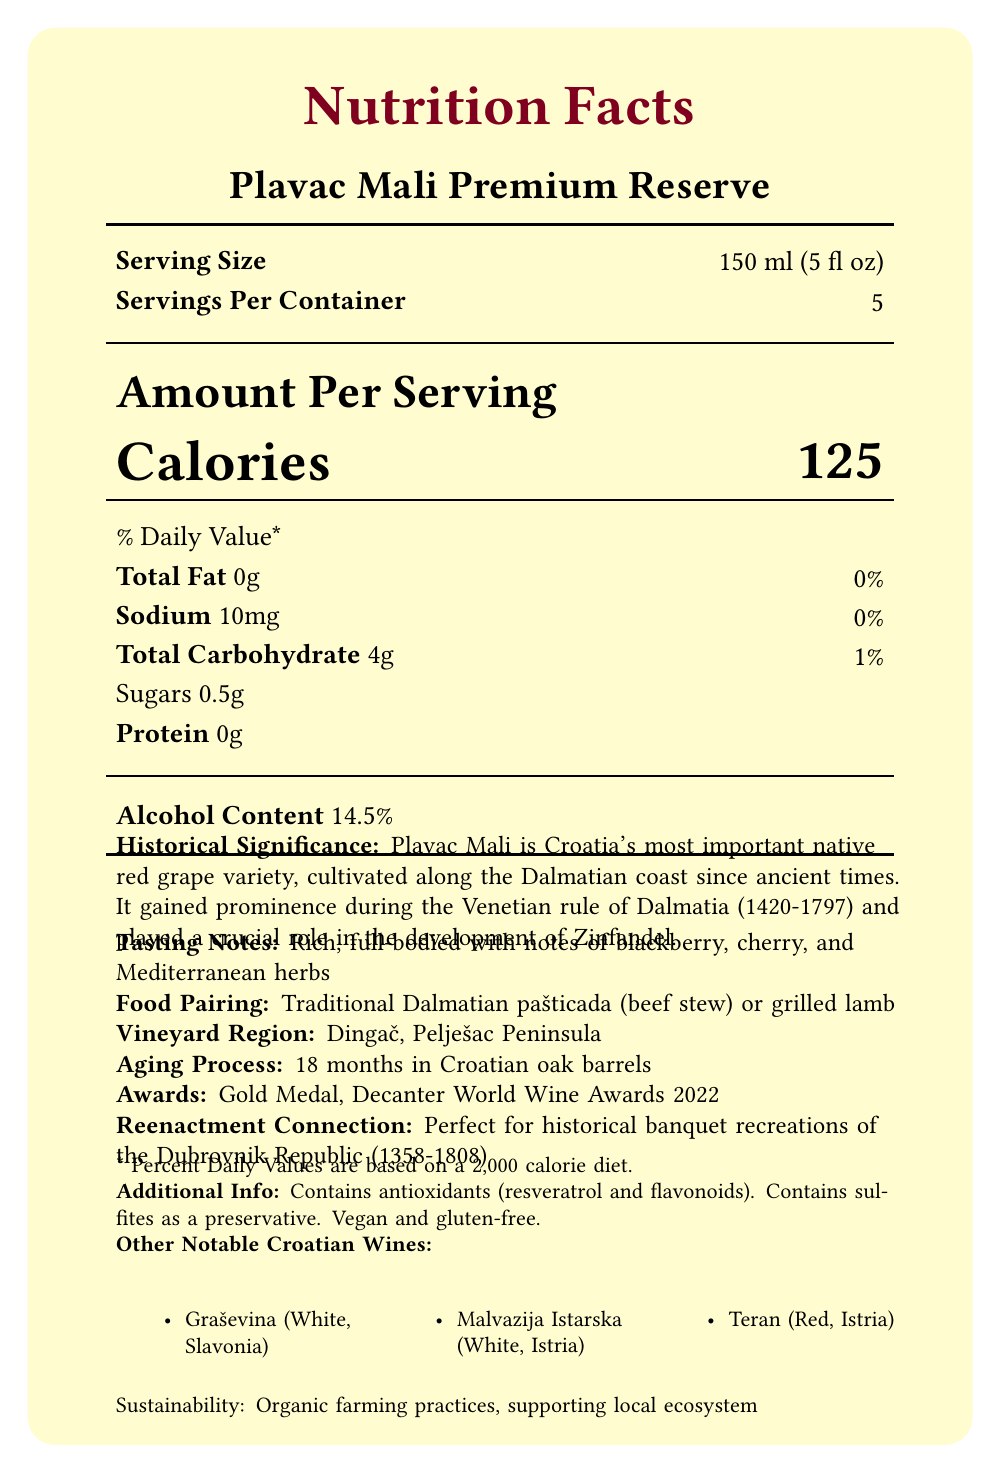what is the serving size of Plavac Mali Premium Reserve? The serving size is explicitly listed as "150 ml (5 fl oz)" in the nutritional information section.
Answer: 150 ml (5 fl oz) how many calories are there per serving? The document specifies that each serving contains 125 calories.
Answer: 125 what is the alcohol content of the wine? The alcohol content is clearly stated as "14.5%" in the nutritional information.
Answer: 14.5% what are the tasting notes for this wine? The document describes the tasting notes as "Rich, full-bodied with notes of blackberry, cherry, and Mediterranean herbs".
Answer: Rich, full-bodied with notes of blackberry, cherry, and Mediterranean herbs which award did Plavac Mali Premium Reserve win and in what year? The awards section states that the wine won the Gold Medal at the Decanter World Wine Awards 2022.
Answer: Gold Medal, Decanter World Wine Awards 2022 how many servings are there in one container of Plavac Mali Premium Reserve? A. 4 B. 5 C. 6 D. 7 The document mentions that there are "5 servings per container".
Answer: B. 5 what food is recommended to pair with this wine? A. Sushi B. Traditional Dalmatian pašticada (beef stew) C. Cheesecake D. Pizza The food pairing section suggests pairing the wine with "Traditional Dalmatian pašticada (beef stew) or grilled lamb".
Answer: B. Traditional Dalmatian pašticada (beef stew) is this wine suitable for vegans? The additional info section confirms that the wine is vegan.
Answer: Yes does the wine contain any sulfites? The additional info section states that the wine contains sulfites as a preservative.
Answer: Yes summarize the main idea of the document. The summary captures all the key sections of the document including nutritional information, historical significance, tasting notes, awards, and additional notable Croatian wines.
Answer: The document provides detailed nutritional facts, historical significance, and additional information about Plavac Mali Premium Reserve, a Croatian red wine. It highlights aspects such as serving size, calories, alcohol content, tasting notes, food pairings, vineyard region, awards, and its suitability for reenactment events. It also mentions other notable Croatian wines. what is the historical connection of Plavac Mali to the Dubrovnik Republic? The reenactment connection section explains that this wine is perfect for historical banquet recreations of the Dubrovnik Republic era.
Answer: Perfect for historical banquet recreations of the Dubrovnik Republic (1358-1808) which red wine grown in Istria is listed among the other notable Croatian wines? The document lists Teran as a notable Croatian red wine from Istria, with historical records dating back to the Roman Empire.
Answer: Teran can the exact year when Venetian traders introduced Malvazija Istarska be determined from the document? The document states that Malvazija Istarska was introduced by Venetian traders in the 14th century, but it does not specify an exact year.
Answer: No, it only mentions that it was introduced in the 14th century, not the exact year. 